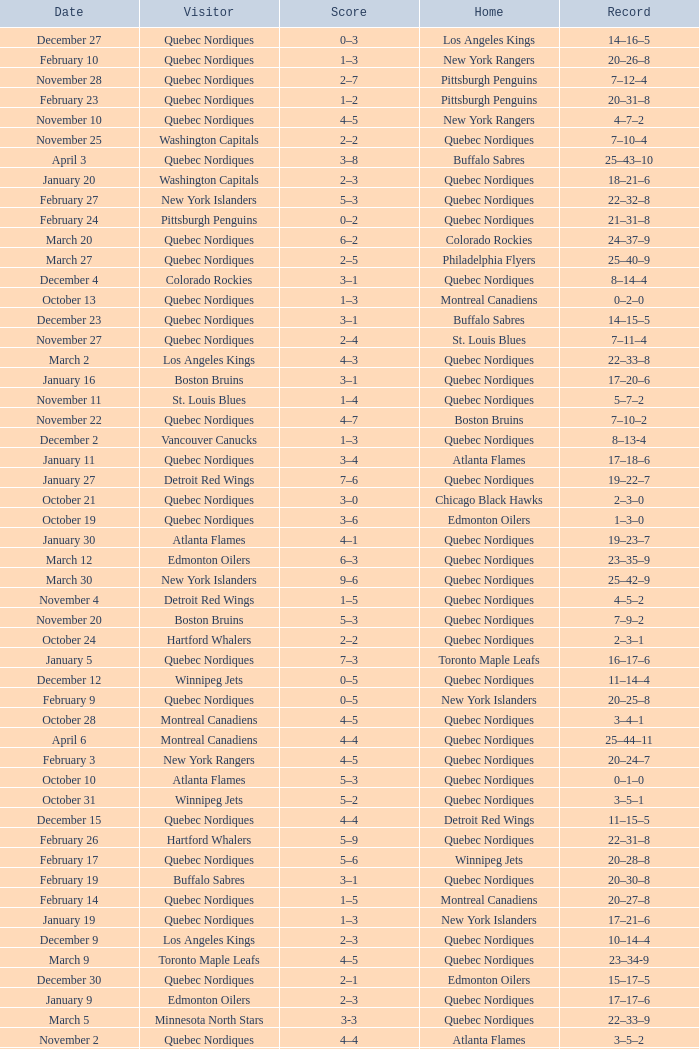Which Home has a Record of 16–17–6? Toronto Maple Leafs. 